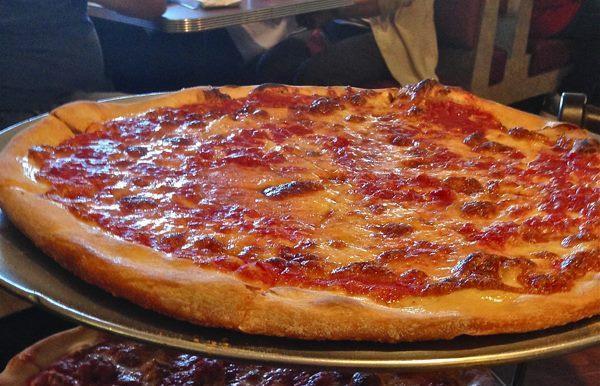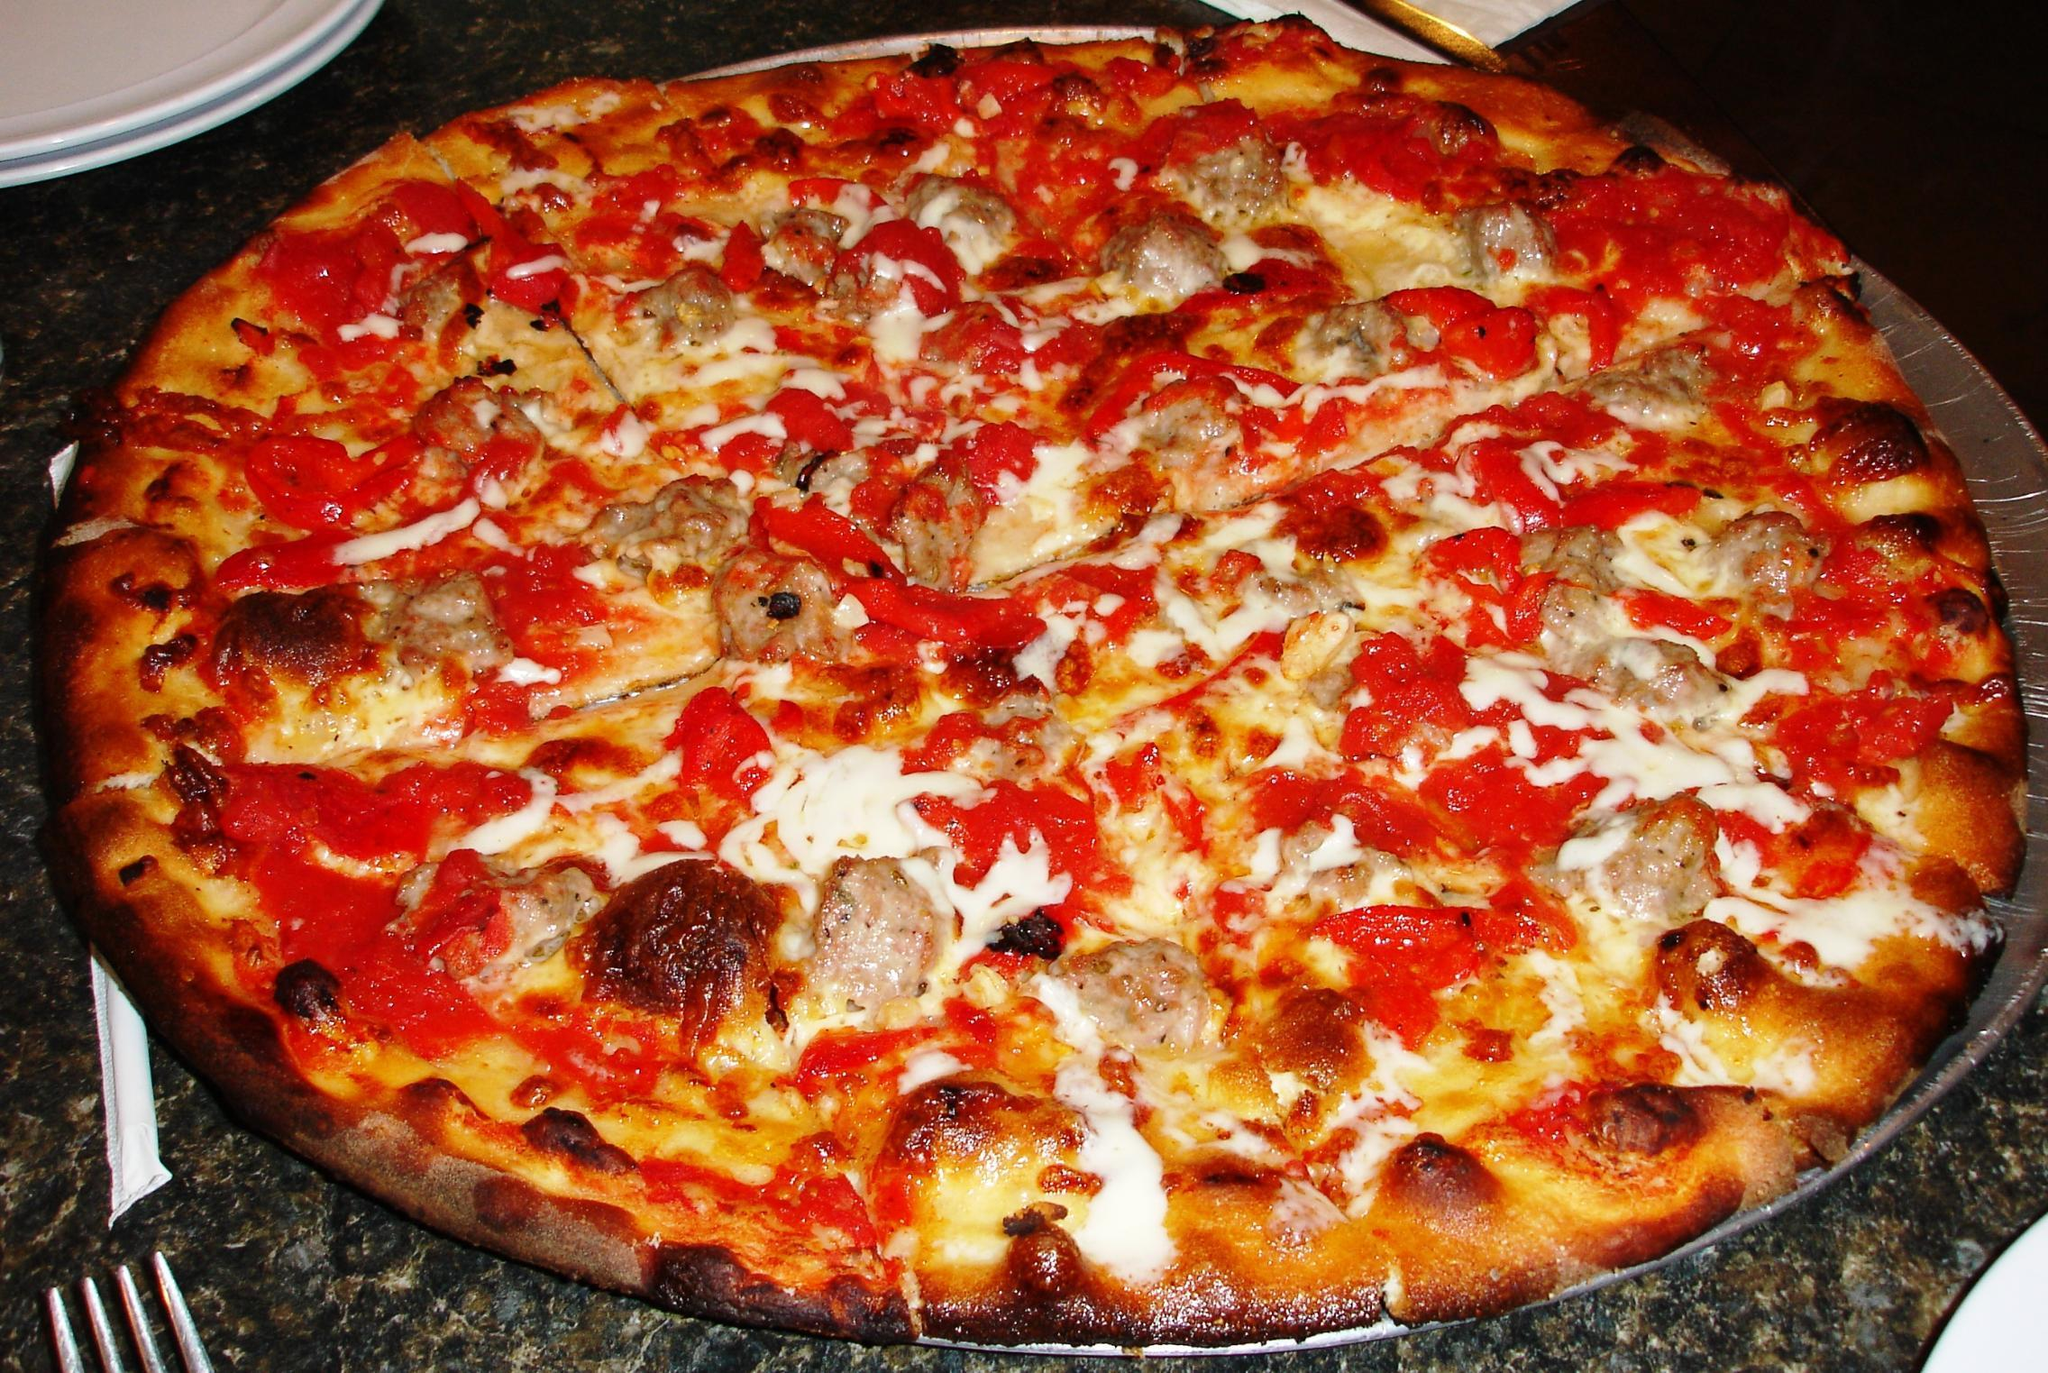The first image is the image on the left, the second image is the image on the right. For the images displayed, is the sentence "Large slices of tomato sit on top of a pizza." factually correct? Answer yes or no. No. The first image is the image on the left, the second image is the image on the right. For the images shown, is this caption "Each image shows a pizza with no slices removed, and one image features a pizza topped with round tomato slices and a green leafy garnish." true? Answer yes or no. No. 